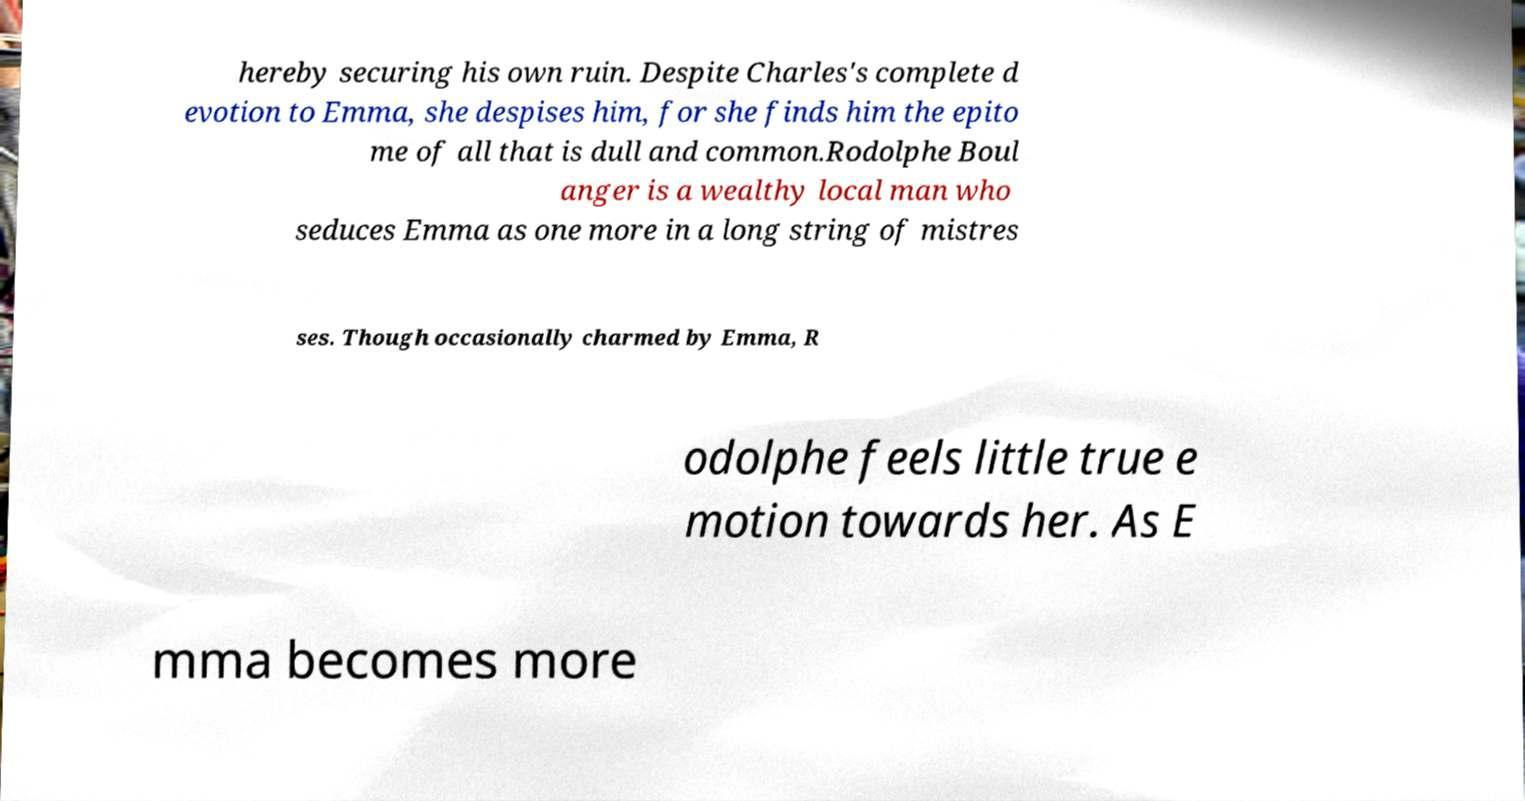Can you accurately transcribe the text from the provided image for me? hereby securing his own ruin. Despite Charles's complete d evotion to Emma, she despises him, for she finds him the epito me of all that is dull and common.Rodolphe Boul anger is a wealthy local man who seduces Emma as one more in a long string of mistres ses. Though occasionally charmed by Emma, R odolphe feels little true e motion towards her. As E mma becomes more 